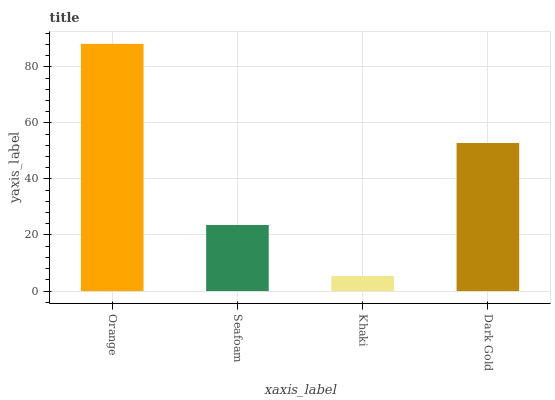Is Khaki the minimum?
Answer yes or no. Yes. Is Orange the maximum?
Answer yes or no. Yes. Is Seafoam the minimum?
Answer yes or no. No. Is Seafoam the maximum?
Answer yes or no. No. Is Orange greater than Seafoam?
Answer yes or no. Yes. Is Seafoam less than Orange?
Answer yes or no. Yes. Is Seafoam greater than Orange?
Answer yes or no. No. Is Orange less than Seafoam?
Answer yes or no. No. Is Dark Gold the high median?
Answer yes or no. Yes. Is Seafoam the low median?
Answer yes or no. Yes. Is Seafoam the high median?
Answer yes or no. No. Is Khaki the low median?
Answer yes or no. No. 